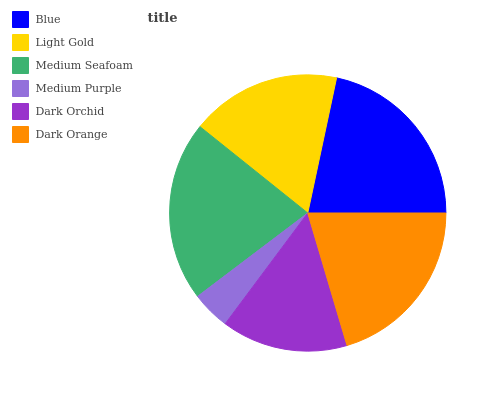Is Medium Purple the minimum?
Answer yes or no. Yes. Is Blue the maximum?
Answer yes or no. Yes. Is Light Gold the minimum?
Answer yes or no. No. Is Light Gold the maximum?
Answer yes or no. No. Is Blue greater than Light Gold?
Answer yes or no. Yes. Is Light Gold less than Blue?
Answer yes or no. Yes. Is Light Gold greater than Blue?
Answer yes or no. No. Is Blue less than Light Gold?
Answer yes or no. No. Is Dark Orange the high median?
Answer yes or no. Yes. Is Light Gold the low median?
Answer yes or no. Yes. Is Medium Purple the high median?
Answer yes or no. No. Is Medium Seafoam the low median?
Answer yes or no. No. 